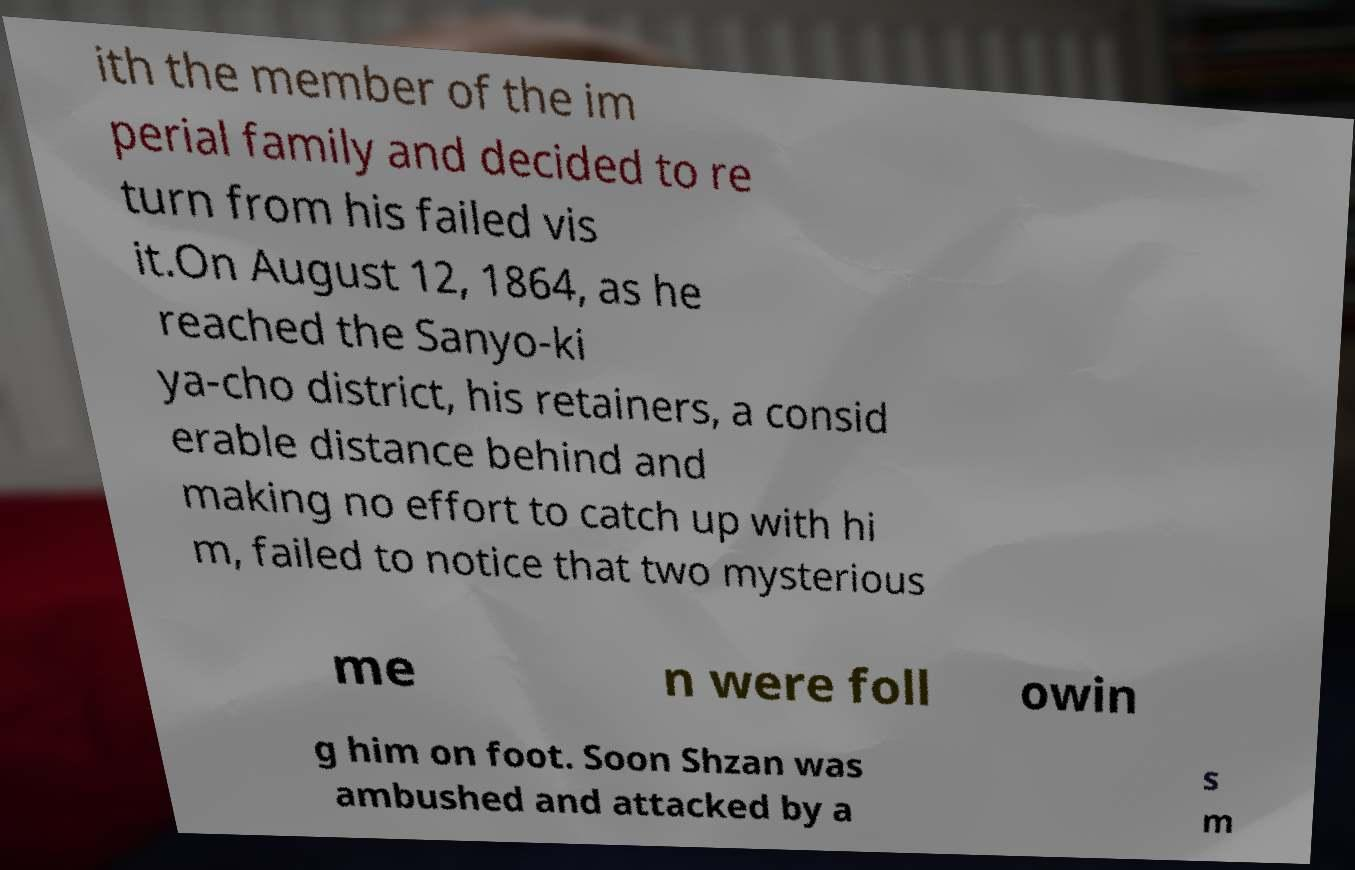Could you assist in decoding the text presented in this image and type it out clearly? ith the member of the im perial family and decided to re turn from his failed vis it.On August 12, 1864, as he reached the Sanyo-ki ya-cho district, his retainers, a consid erable distance behind and making no effort to catch up with hi m, failed to notice that two mysterious me n were foll owin g him on foot. Soon Shzan was ambushed and attacked by a s m 